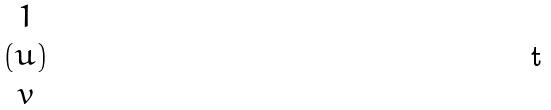Convert formula to latex. <formula><loc_0><loc_0><loc_500><loc_500>( \begin{matrix} 1 \\ u \\ v \end{matrix} )</formula> 